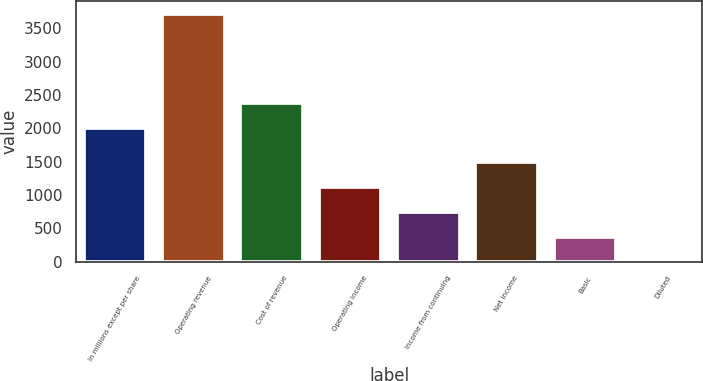<chart> <loc_0><loc_0><loc_500><loc_500><bar_chart><fcel>In millions except per share<fcel>Operating revenue<fcel>Cost of revenue<fcel>Operating income<fcel>Income from continuing<fcel>Net income<fcel>Basic<fcel>Diluted<nl><fcel>2014<fcel>3719<fcel>2385.78<fcel>1116.55<fcel>744.77<fcel>1492<fcel>372.99<fcel>1.21<nl></chart> 